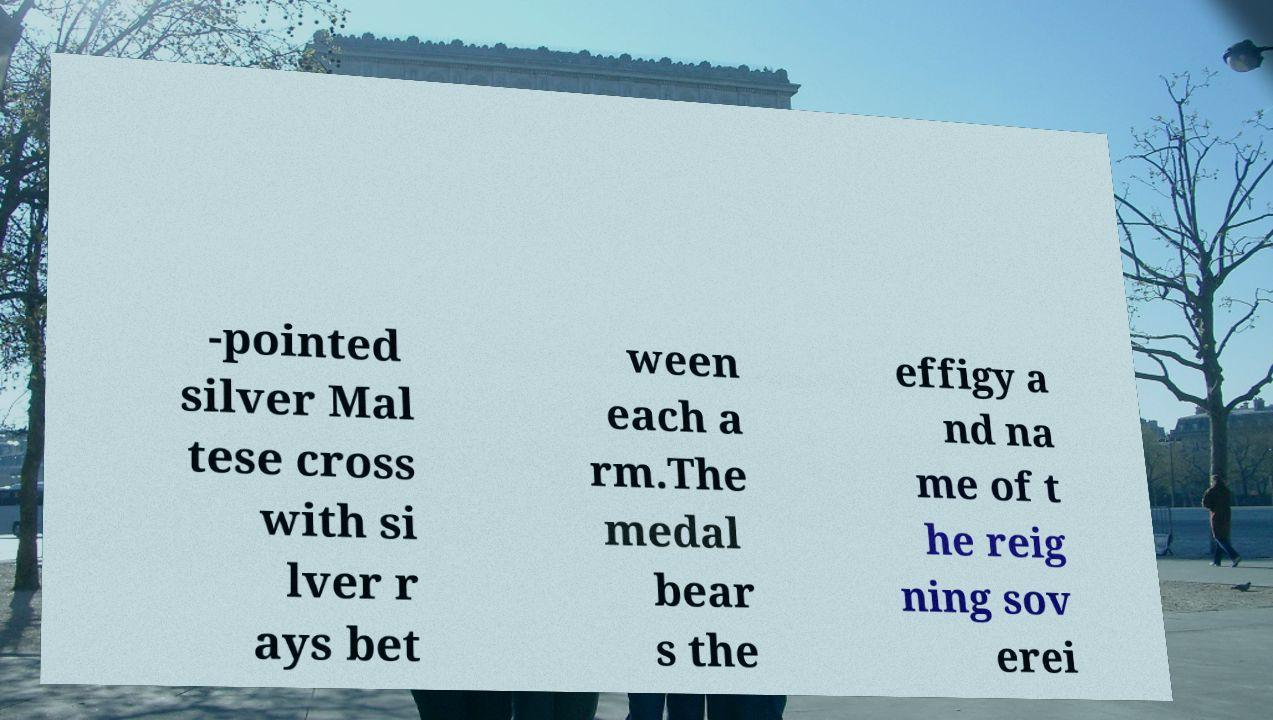Please identify and transcribe the text found in this image. -pointed silver Mal tese cross with si lver r ays bet ween each a rm.The medal bear s the effigy a nd na me of t he reig ning sov erei 